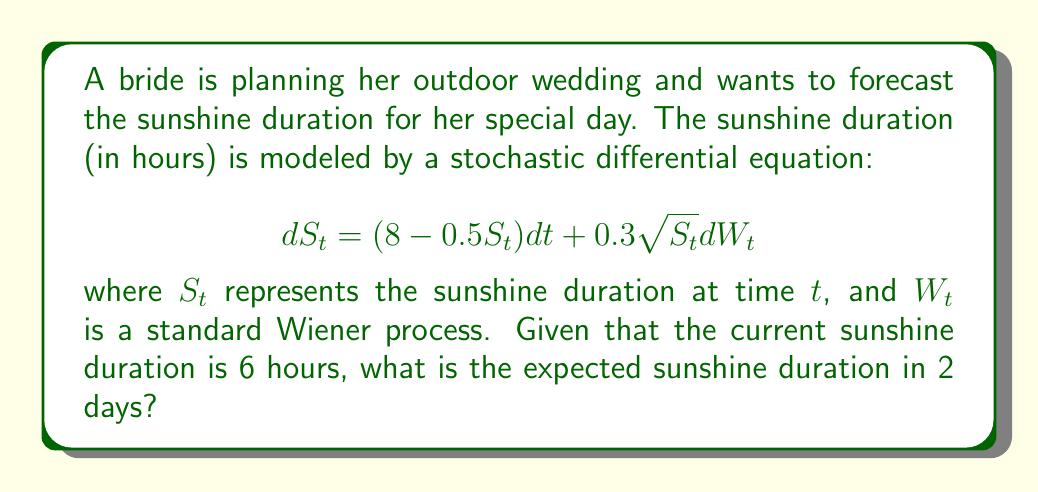Help me with this question. To solve this problem, we need to follow these steps:

1) First, we identify the given stochastic differential equation (SDE) as a Cox-Ingersoll-Ross (CIR) process. The general form of a CIR process is:

   $$dX_t = \kappa(\theta - X_t)dt + \sigma\sqrt{X_t}dW_t$$

2) In our case, comparing with the given SDE:
   $\kappa = 0.5$, $\theta = 16$, and $\sigma = 0.3$

3) For a CIR process, the expected value at time $t$, given the initial value $X_0$, is:

   $$E[X_t|X_0] = X_0e^{-\kappa t} + \theta(1 - e^{-\kappa t})$$

4) In our problem:
   $X_0 = 6$ (current sunshine duration)
   $t = 2$ (we want to forecast 2 days ahead)
   $\theta = 16$
   $\kappa = 0.5$

5) Substituting these values into the formula:

   $$E[S_2|S_0 = 6] = 6e^{-0.5 \cdot 2} + 16(1 - e^{-0.5 \cdot 2})$$

6) Simplify:
   $$= 6e^{-1} + 16(1 - e^{-1})$$
   $$= 6/e + 16 - 16/e$$
   $$= 16 - 10/e$$
   $$\approx 12.32$$

Therefore, the expected sunshine duration in 2 days is approximately 12.32 hours.
Answer: 12.32 hours 